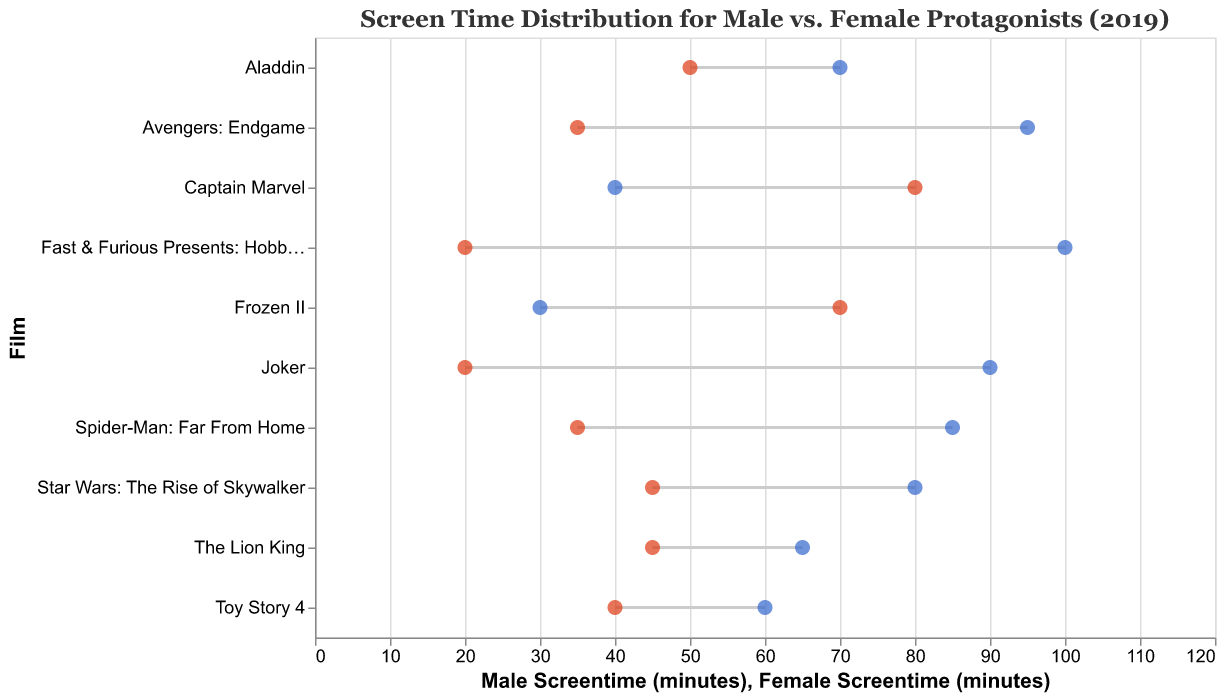What is the title of the plot? The title is displayed at the top of the plot. It reads: "Screen Time Distribution for Male vs. Female Protagonists (2019)".
Answer: Screen Time Distribution for Male vs. Female Protagonists (2019) Which film has the highest male screentime? By looking at the horizontal bars representing each film, the film with the highest point on the male screentime axis is "Fast & Furious Presents: Hobbs & Shaw".
Answer: Fast & Furious Presents: Hobbs & Shaw What is the screentime difference between male and female protagonists for Frozen II? Frozen II has 30 minutes of male screentime and 70 minutes of female screentime. The difference is calculated as 70 - 30 = 40.
Answer: 40 minutes Which film shows more screentime for female protagonists compared to male protagonists? Look for the lines where the endpoint for female screentime is to the right of the male endpoint. "Frozen II" and "Captain Marvel" fit this criterion.
Answer: Frozen II, Captain Marvel How many films have more male screentime than female screentime? Count the lines where the point for male screentime is farther to the right than the female endpoint. There are 8 such films.
Answer: 8 films What is the average male screentime across all listed films? Sum the male screentime values: 95+30+90+40+85+70+60+80+100+65 = 715. Divide by the number of films (10). 715/10 = 71.5.
Answer: 71.5 minutes Which film has the smallest difference in screentime between male and female protagonists? Calculate the absolute differences for each film. "Aladdin" has 70 (male) - 50 (female) = 20 minutes, which is the smallest difference among the films.
Answer: Aladdin Between "Avengers: Endgame" and "Spider-Man: Far From Home", which film has a higher female screentime? Look at the female screentime points for both films. "Avengers: Endgame" has 35 minutes, whereas "Spider-Man: Far From Home" has 35 minutes. Since both have the same screentime, neither film has higher female screentime.
Answer: They are equal Which film has the largest difference in screentime between male and female protagonists? Identify the lines with the largest gap between points. "Fast & Furious Presents: Hobbs & Shaw" has a difference of 100 (male) - 20 (female) = 80 minutes.
Answer: Fast & Furious Presents: Hobbs & Shaw What is the total screentime for female protagonists across all films? Sum the female screentime values: 35+70+20+80+35+50+40+45+20+45 = 440.
Answer: 440 minutes 